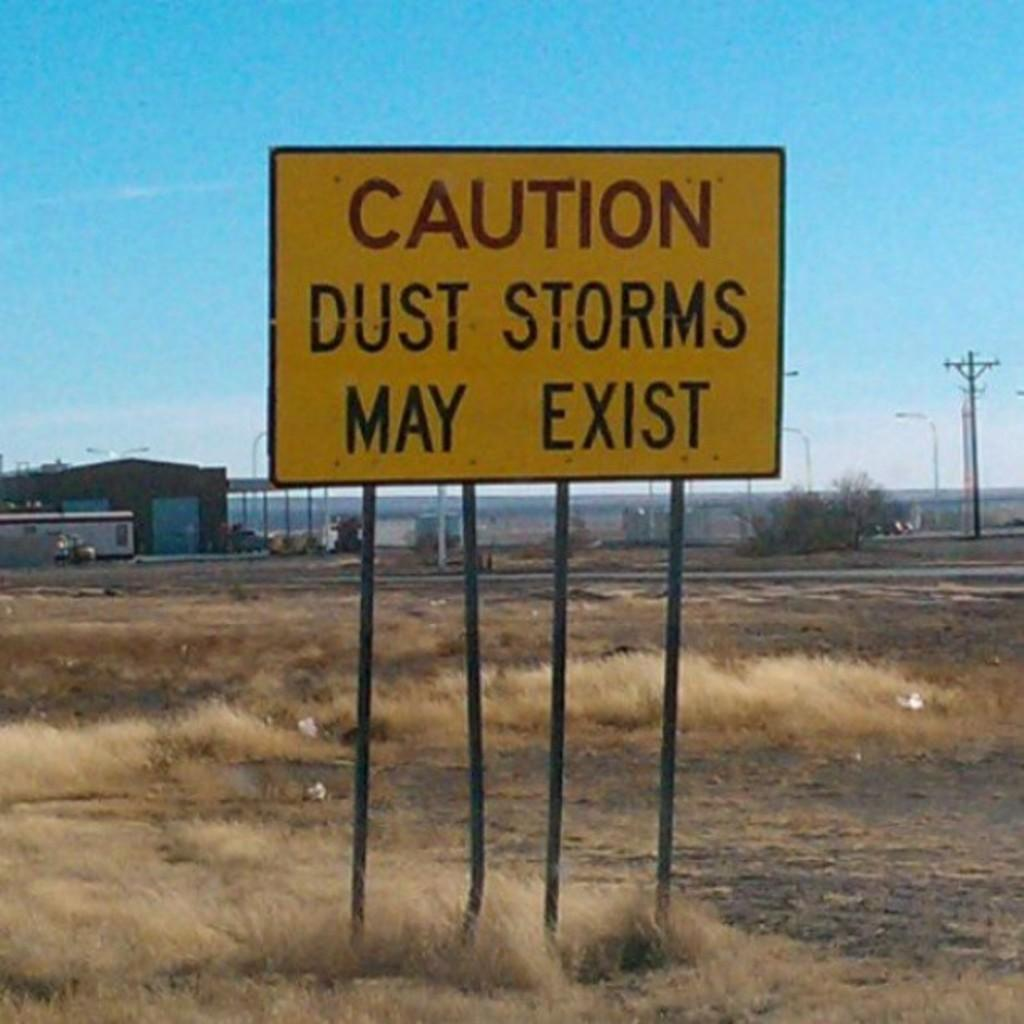<image>
Render a clear and concise summary of the photo. A sign in a deserted area with run down buildings behind it reads Caution, Dust Storms May Exist. 